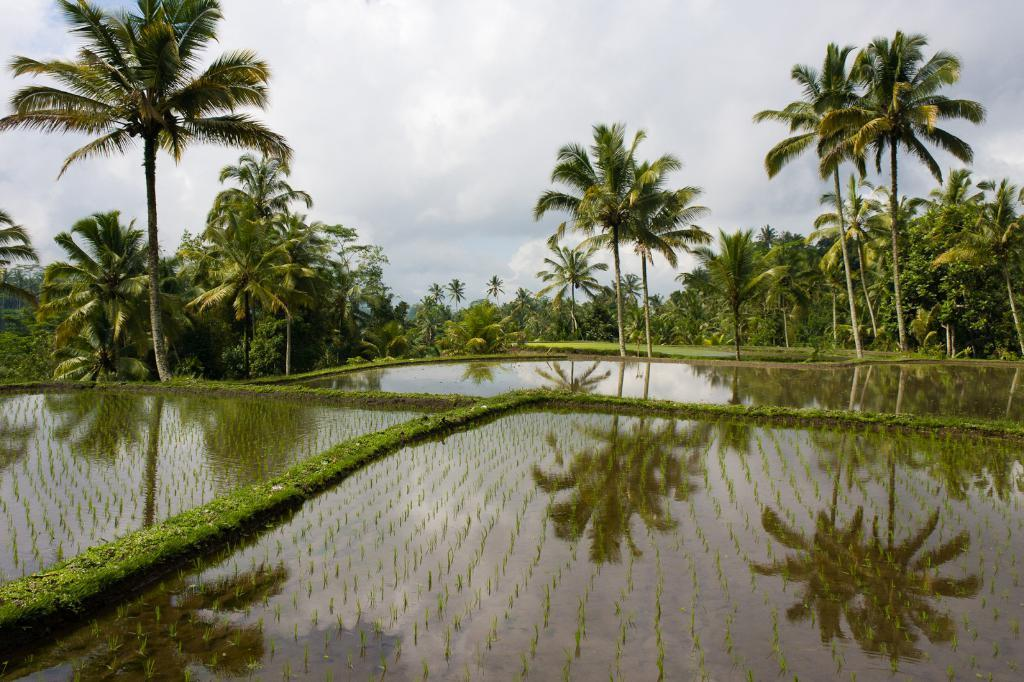What type of landscape is depicted at the bottom of the image? There are fields with water at the bottom of the image. What can be seen in the background of the image? There are trees in the background of the image. What is visible at the top of the image? The sky is visible at the top of the image. What is the condition of the sky in the image? Clouds are present in the sky. How many slaves can be seen working in the fields in the image? There are no slaves present in the image; it depicts fields with water and trees in the background. What type of material is being rubbed on the trees in the image? There is no indication of any material being rubbed on the trees in the image. 